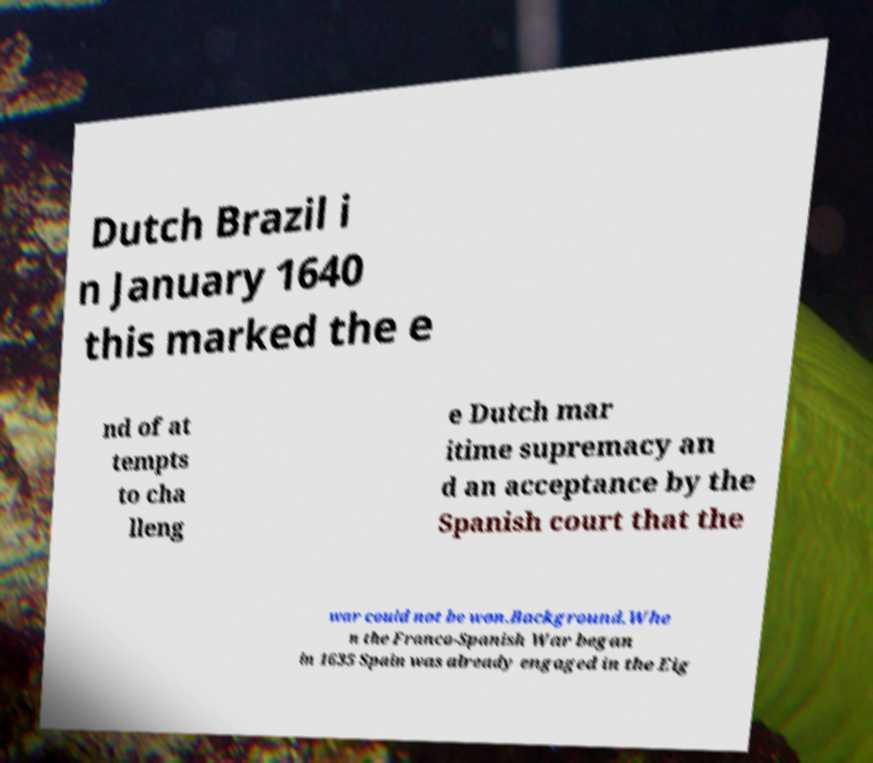Can you read and provide the text displayed in the image?This photo seems to have some interesting text. Can you extract and type it out for me? Dutch Brazil i n January 1640 this marked the e nd of at tempts to cha lleng e Dutch mar itime supremacy an d an acceptance by the Spanish court that the war could not be won.Background.Whe n the Franco-Spanish War began in 1635 Spain was already engaged in the Eig 